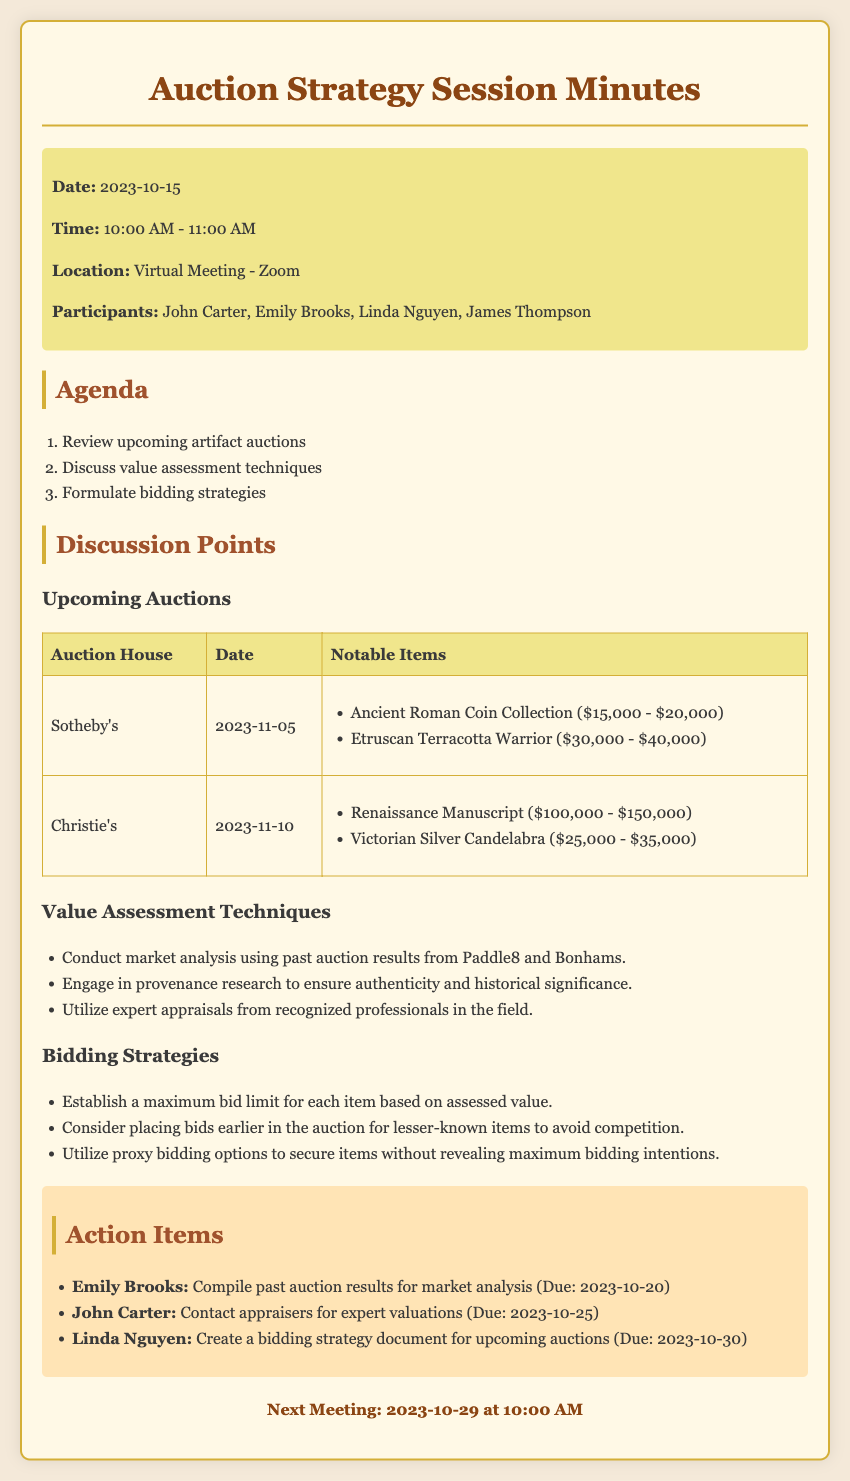What is the date of the next meeting? The next meeting is scheduled for October 29, 2023, according to the document.
Answer: 2023-10-29 Who is responsible for compiling past auction results? The document states that Emily Brooks is responsible for this action item.
Answer: Emily Brooks What is the highest estimated value item at Christie's? Referring to Christie's notable items, the Renaissance Manuscript has the highest estimated value.
Answer: Renaissance Manuscript When is Sotheby's auction? The auction date for Sotheby's is provided in the upcoming auctions section.
Answer: 2023-11-05 What strategy is suggested for bidding on lesser-known items? The document recommends placing bids earlier to avoid competition for these items.
Answer: Place bids earlier What will Linda Nguyen create for the upcoming auctions? The action item specifies that Linda Nguyen will create a bidding strategy document.
Answer: Bidding strategy document What is the estimated value range for the Etruscan Terracotta Warrior? The document lists the estimated value range for this item.
Answer: $30,000 - $40,000 Which auction house is hosting an auction on November 10? The document clearly states that Christie's is hosting an auction on this date.
Answer: Christie's 